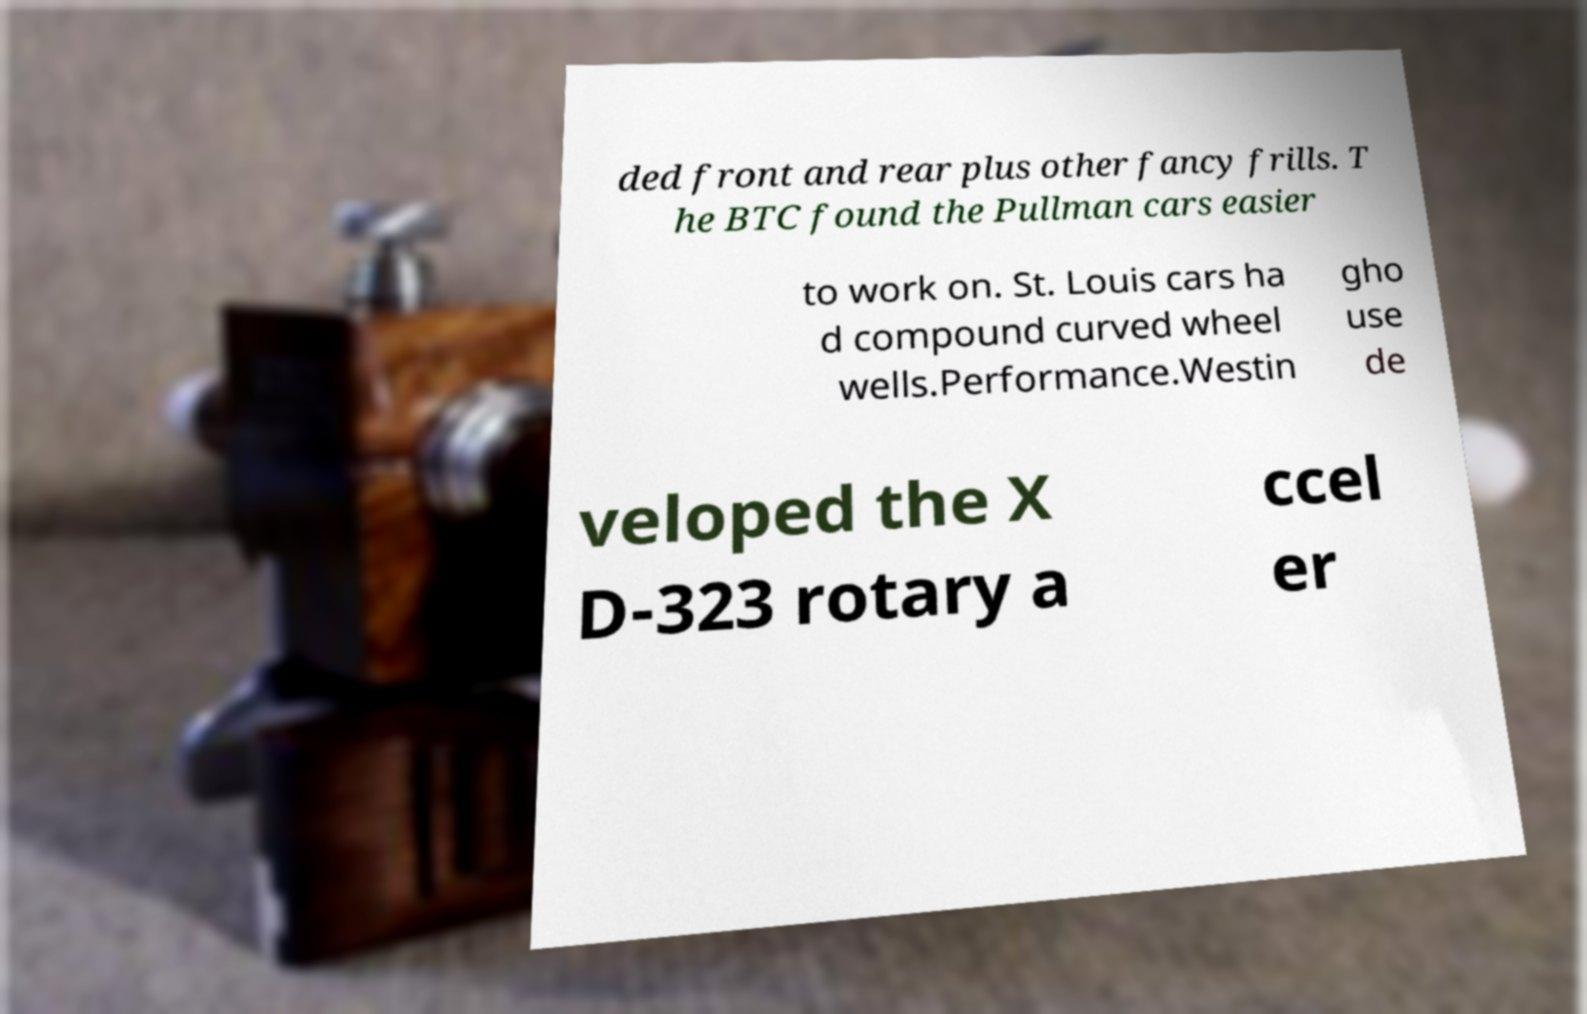For documentation purposes, I need the text within this image transcribed. Could you provide that? ded front and rear plus other fancy frills. T he BTC found the Pullman cars easier to work on. St. Louis cars ha d compound curved wheel wells.Performance.Westin gho use de veloped the X D-323 rotary a ccel er 